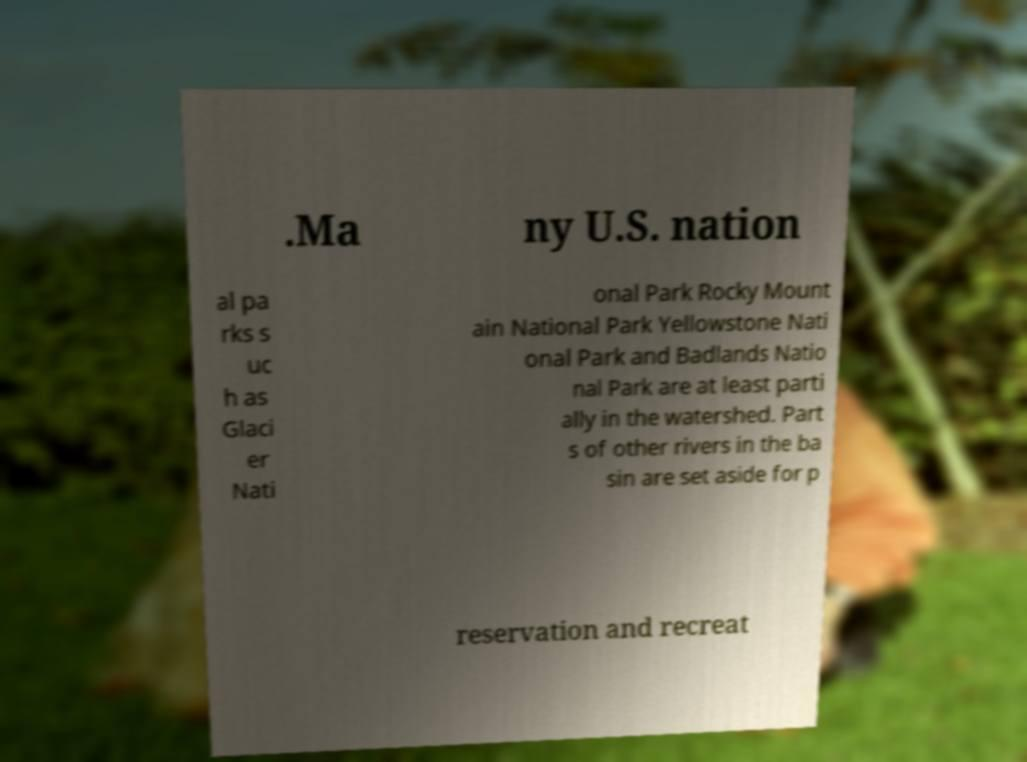Could you extract and type out the text from this image? .Ma ny U.S. nation al pa rks s uc h as Glaci er Nati onal Park Rocky Mount ain National Park Yellowstone Nati onal Park and Badlands Natio nal Park are at least parti ally in the watershed. Part s of other rivers in the ba sin are set aside for p reservation and recreat 